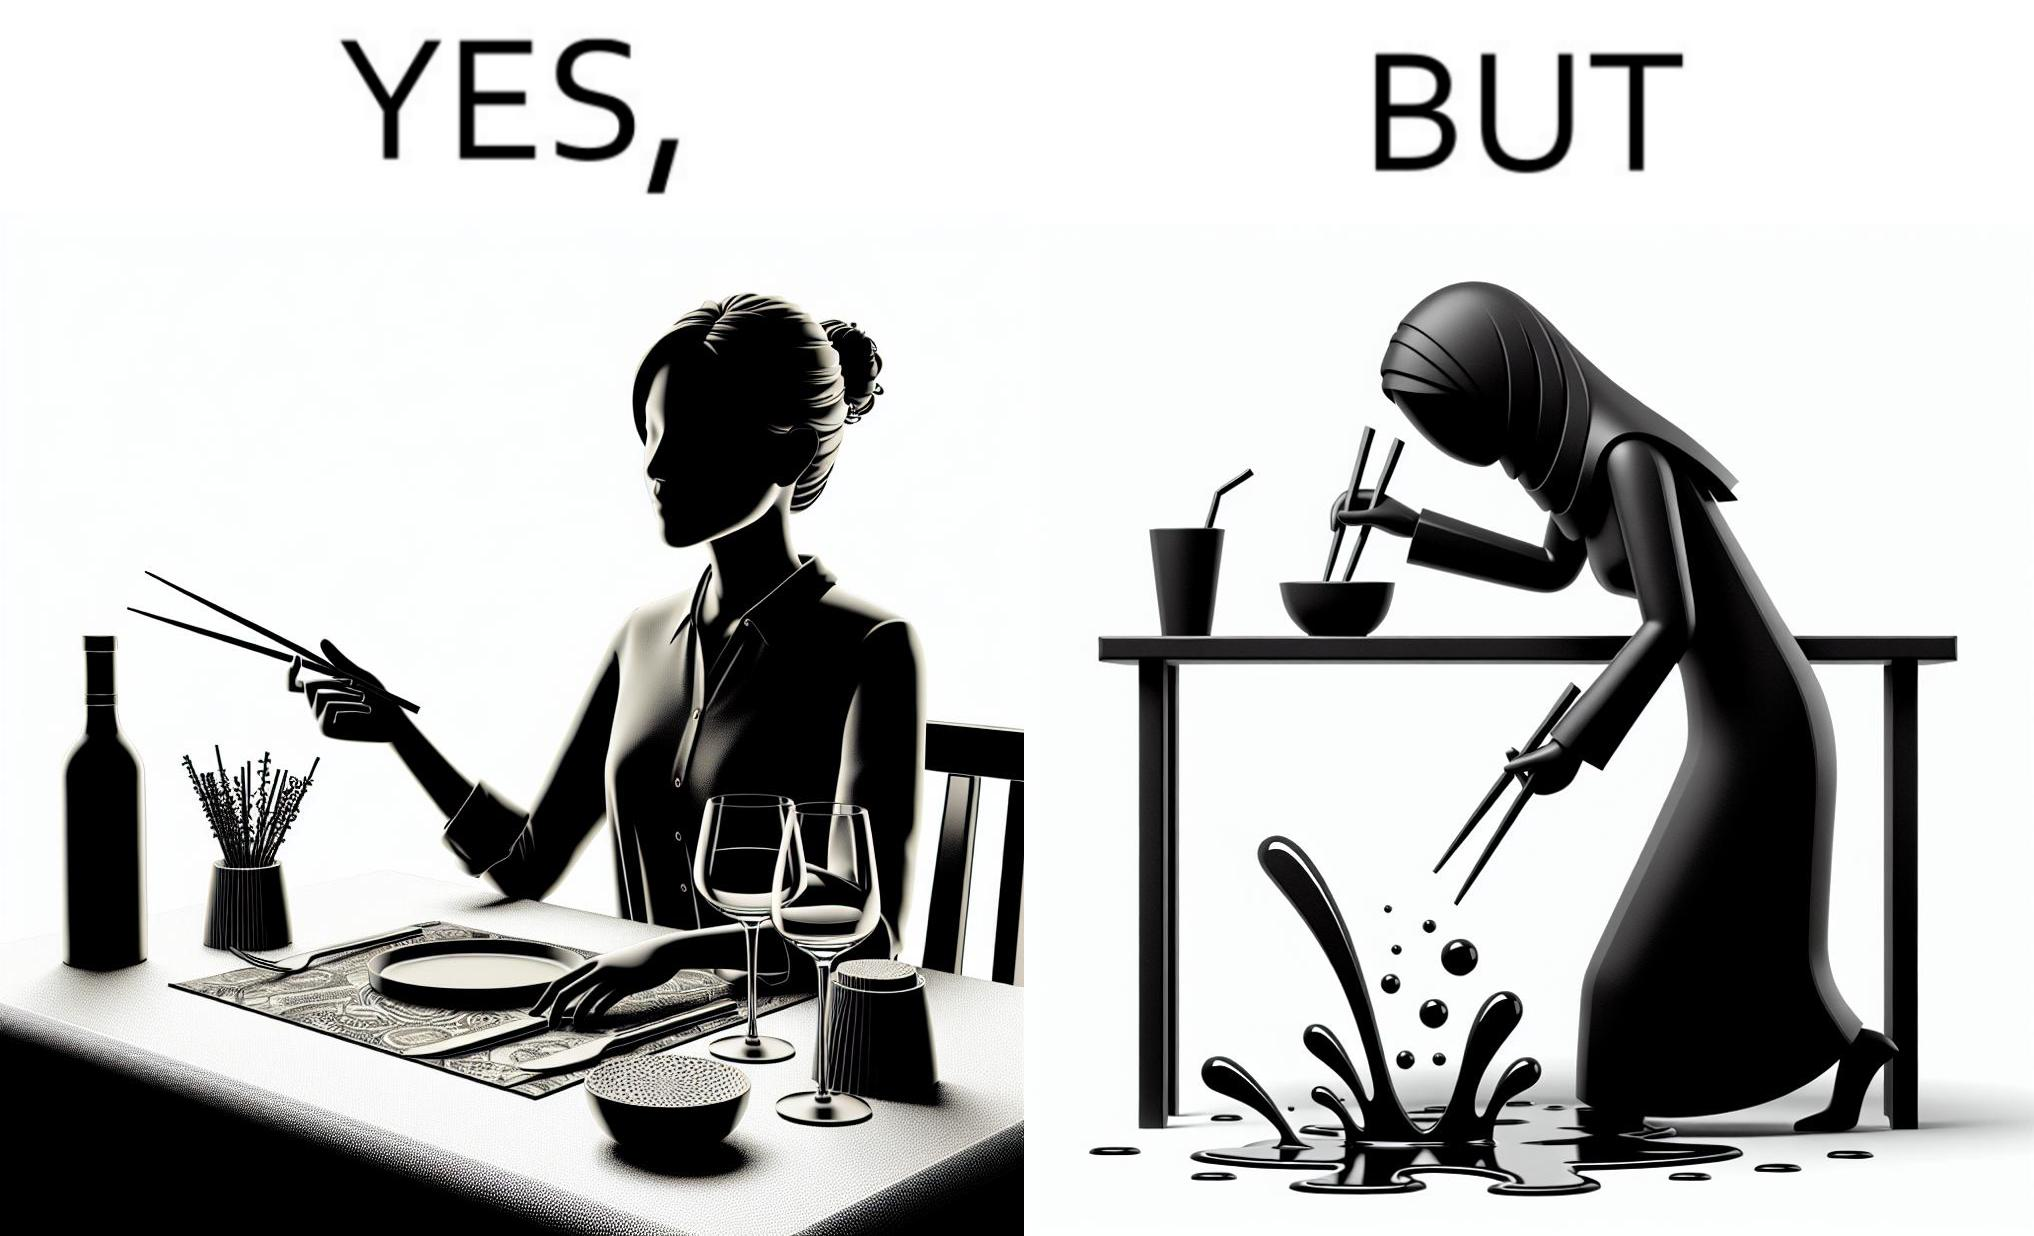What is shown in the left half versus the right half of this image? In the left part of the image: The image shows a woman sitting at a table in a restaruant pointing to chopsticks on her table. There is also a wine glass, a fork and a knief on her table. In the right part of the image: The image shows a person using chopstick to pick up food from the cup. The person is not able to handle food with chopstick well and is dropping the food around the cup on the table. 